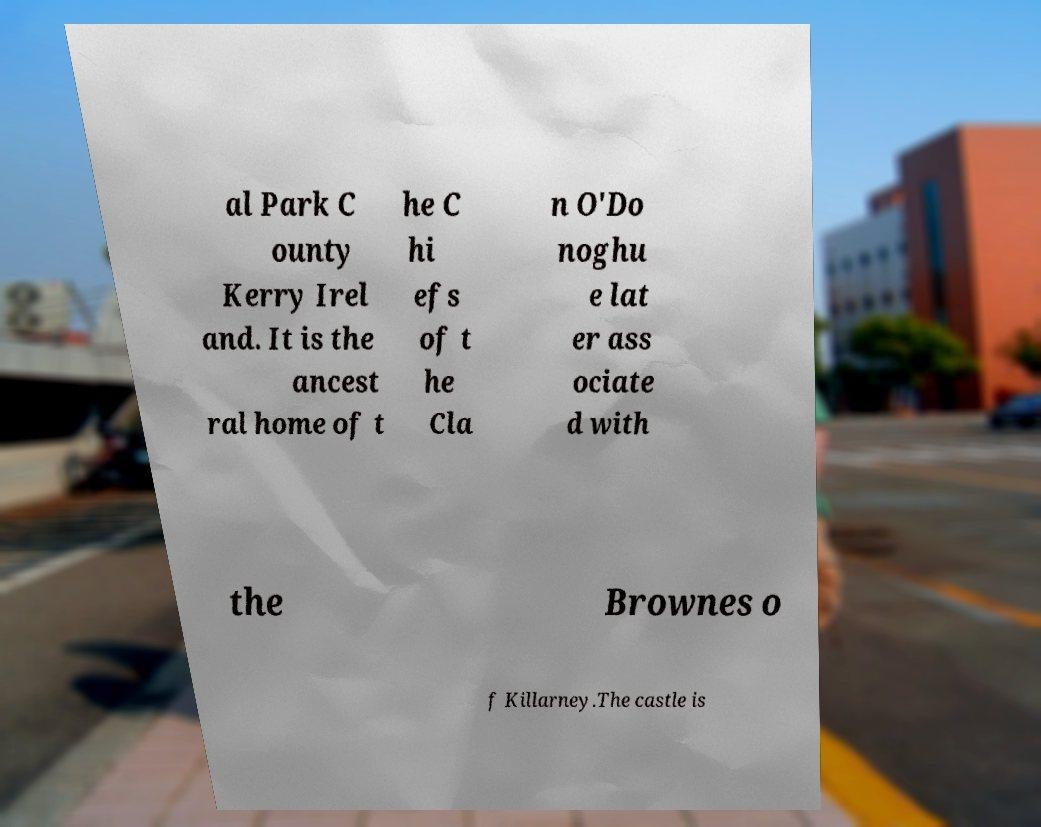Could you assist in decoding the text presented in this image and type it out clearly? al Park C ounty Kerry Irel and. It is the ancest ral home of t he C hi efs of t he Cla n O'Do noghu e lat er ass ociate d with the Brownes o f Killarney.The castle is 